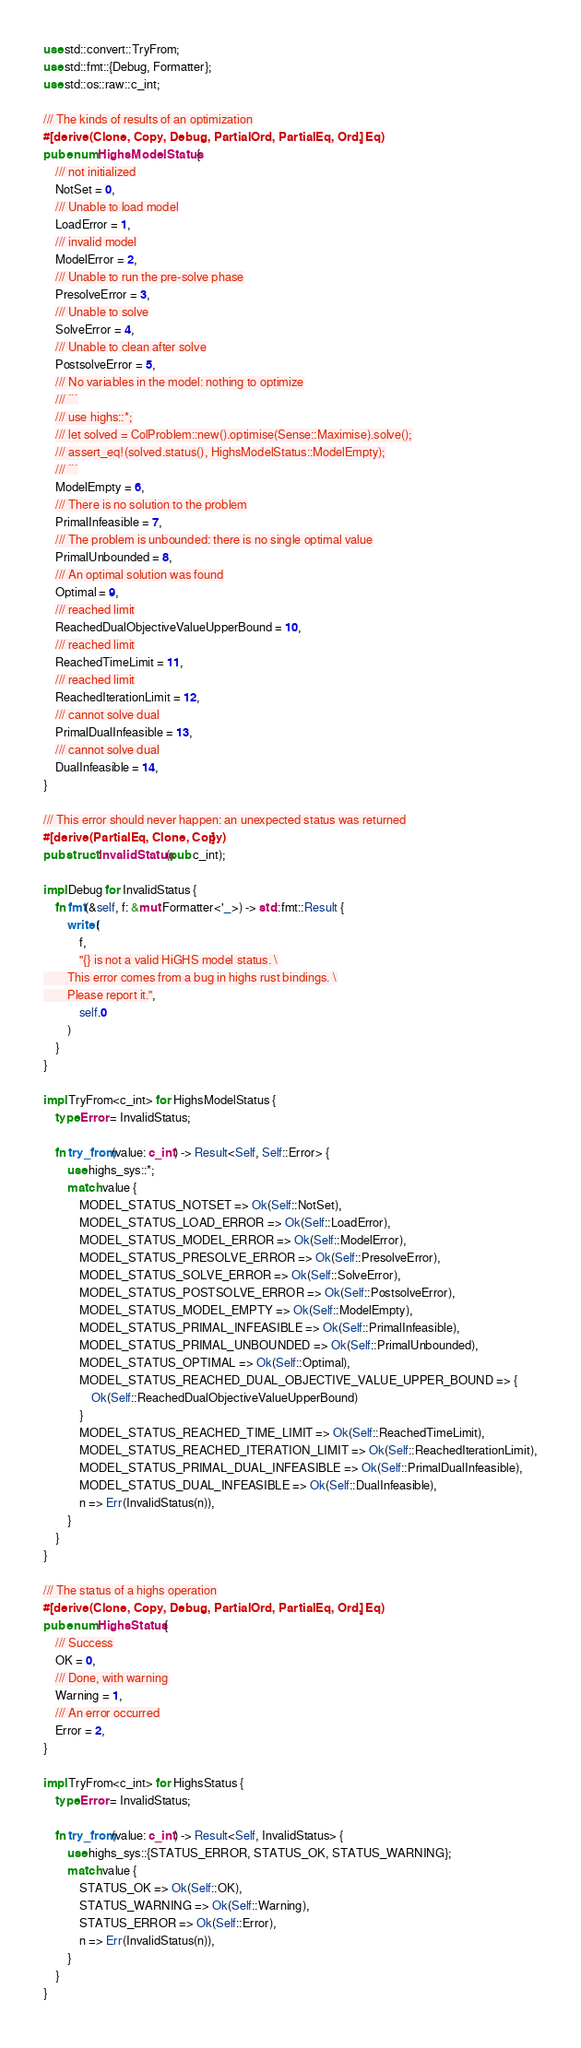Convert code to text. <code><loc_0><loc_0><loc_500><loc_500><_Rust_>use std::convert::TryFrom;
use std::fmt::{Debug, Formatter};
use std::os::raw::c_int;

/// The kinds of results of an optimization
#[derive(Clone, Copy, Debug, PartialOrd, PartialEq, Ord, Eq)]
pub enum HighsModelStatus {
    /// not initialized
    NotSet = 0,
    /// Unable to load model
    LoadError = 1,
    /// invalid model
    ModelError = 2,
    /// Unable to run the pre-solve phase
    PresolveError = 3,
    /// Unable to solve
    SolveError = 4,
    /// Unable to clean after solve
    PostsolveError = 5,
    /// No variables in the model: nothing to optimize
    /// ```
    /// use highs::*;
    /// let solved = ColProblem::new().optimise(Sense::Maximise).solve();
    /// assert_eq!(solved.status(), HighsModelStatus::ModelEmpty);
    /// ```
    ModelEmpty = 6,
    /// There is no solution to the problem
    PrimalInfeasible = 7,
    /// The problem is unbounded: there is no single optimal value
    PrimalUnbounded = 8,
    /// An optimal solution was found
    Optimal = 9,
    /// reached limit
    ReachedDualObjectiveValueUpperBound = 10,
    /// reached limit
    ReachedTimeLimit = 11,
    /// reached limit
    ReachedIterationLimit = 12,
    /// cannot solve dual
    PrimalDualInfeasible = 13,
    /// cannot solve dual
    DualInfeasible = 14,
}

/// This error should never happen: an unexpected status was returned
#[derive(PartialEq, Clone, Copy)]
pub struct InvalidStatus(pub c_int);

impl Debug for InvalidStatus {
    fn fmt(&self, f: &mut Formatter<'_>) -> std::fmt::Result {
        write!(
            f,
            "{} is not a valid HiGHS model status. \
        This error comes from a bug in highs rust bindings. \
        Please report it.",
            self.0
        )
    }
}

impl TryFrom<c_int> for HighsModelStatus {
    type Error = InvalidStatus;

    fn try_from(value: c_int) -> Result<Self, Self::Error> {
        use highs_sys::*;
        match value {
            MODEL_STATUS_NOTSET => Ok(Self::NotSet),
            MODEL_STATUS_LOAD_ERROR => Ok(Self::LoadError),
            MODEL_STATUS_MODEL_ERROR => Ok(Self::ModelError),
            MODEL_STATUS_PRESOLVE_ERROR => Ok(Self::PresolveError),
            MODEL_STATUS_SOLVE_ERROR => Ok(Self::SolveError),
            MODEL_STATUS_POSTSOLVE_ERROR => Ok(Self::PostsolveError),
            MODEL_STATUS_MODEL_EMPTY => Ok(Self::ModelEmpty),
            MODEL_STATUS_PRIMAL_INFEASIBLE => Ok(Self::PrimalInfeasible),
            MODEL_STATUS_PRIMAL_UNBOUNDED => Ok(Self::PrimalUnbounded),
            MODEL_STATUS_OPTIMAL => Ok(Self::Optimal),
            MODEL_STATUS_REACHED_DUAL_OBJECTIVE_VALUE_UPPER_BOUND => {
                Ok(Self::ReachedDualObjectiveValueUpperBound)
            }
            MODEL_STATUS_REACHED_TIME_LIMIT => Ok(Self::ReachedTimeLimit),
            MODEL_STATUS_REACHED_ITERATION_LIMIT => Ok(Self::ReachedIterationLimit),
            MODEL_STATUS_PRIMAL_DUAL_INFEASIBLE => Ok(Self::PrimalDualInfeasible),
            MODEL_STATUS_DUAL_INFEASIBLE => Ok(Self::DualInfeasible),
            n => Err(InvalidStatus(n)),
        }
    }
}

/// The status of a highs operation
#[derive(Clone, Copy, Debug, PartialOrd, PartialEq, Ord, Eq)]
pub enum HighsStatus {
    /// Success
    OK = 0,
    /// Done, with warning
    Warning = 1,
    /// An error occurred
    Error = 2,
}

impl TryFrom<c_int> for HighsStatus {
    type Error = InvalidStatus;

    fn try_from(value: c_int) -> Result<Self, InvalidStatus> {
        use highs_sys::{STATUS_ERROR, STATUS_OK, STATUS_WARNING};
        match value {
            STATUS_OK => Ok(Self::OK),
            STATUS_WARNING => Ok(Self::Warning),
            STATUS_ERROR => Ok(Self::Error),
            n => Err(InvalidStatus(n)),
        }
    }
}
</code> 